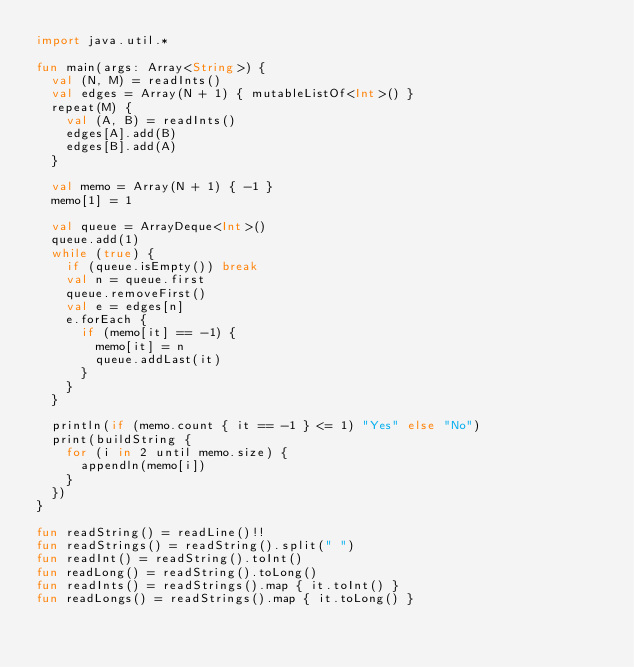Convert code to text. <code><loc_0><loc_0><loc_500><loc_500><_Kotlin_>import java.util.*

fun main(args: Array<String>) {
  val (N, M) = readInts()
  val edges = Array(N + 1) { mutableListOf<Int>() }
  repeat(M) {
    val (A, B) = readInts()
    edges[A].add(B)
    edges[B].add(A)
  }

  val memo = Array(N + 1) { -1 }
  memo[1] = 1

  val queue = ArrayDeque<Int>()
  queue.add(1)
  while (true) {
    if (queue.isEmpty()) break
    val n = queue.first
    queue.removeFirst()
    val e = edges[n]
    e.forEach {
      if (memo[it] == -1) {
        memo[it] = n
        queue.addLast(it)
      }
    }
  }

  println(if (memo.count { it == -1 } <= 1) "Yes" else "No")
  print(buildString {
    for (i in 2 until memo.size) {
      appendln(memo[i])
    }
  })
}

fun readString() = readLine()!!
fun readStrings() = readString().split(" ")
fun readInt() = readString().toInt()
fun readLong() = readString().toLong()
fun readInts() = readStrings().map { it.toInt() }
fun readLongs() = readStrings().map { it.toLong() }
</code> 